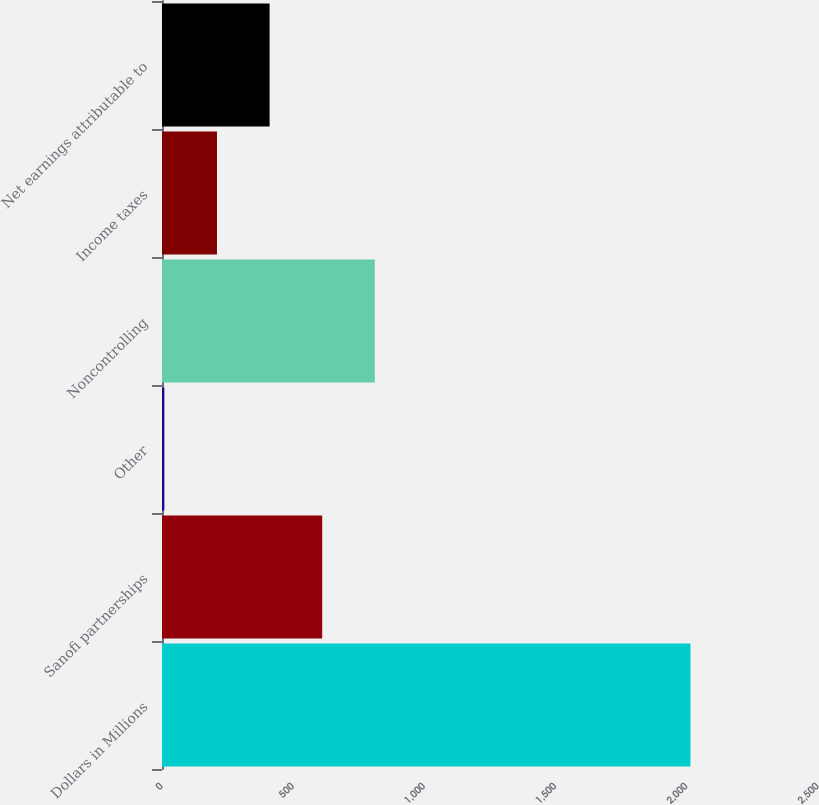<chart> <loc_0><loc_0><loc_500><loc_500><bar_chart><fcel>Dollars in Millions<fcel>Sanofi partnerships<fcel>Other<fcel>Noncontrolling<fcel>Income taxes<fcel>Net earnings attributable to<nl><fcel>2014<fcel>610.5<fcel>9<fcel>811<fcel>209.5<fcel>410<nl></chart> 